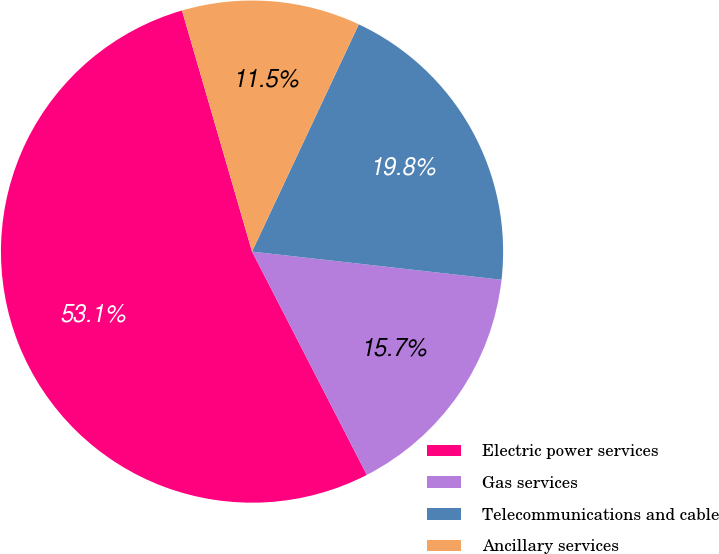<chart> <loc_0><loc_0><loc_500><loc_500><pie_chart><fcel>Electric power services<fcel>Gas services<fcel>Telecommunications and cable<fcel>Ancillary services<nl><fcel>53.06%<fcel>15.65%<fcel>19.8%<fcel>11.49%<nl></chart> 